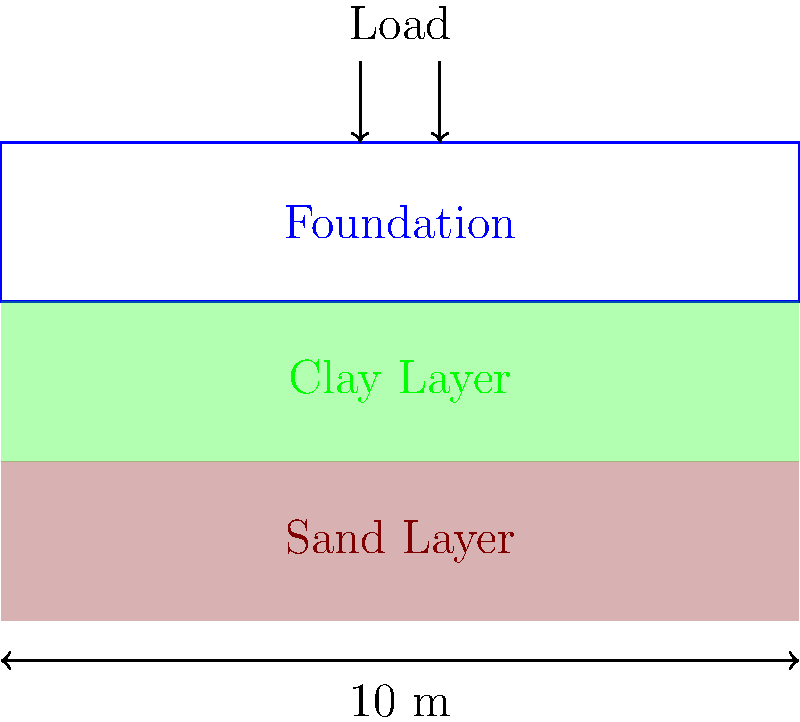A 10-meter wide foundation rests on a two-layer soil profile consisting of a 2-meter thick clay layer over a sand layer. The clay layer has a compression index ($C_c$) of 0.2 and an initial void ratio ($e_0$) of 0.8. The effective overburden pressure ($p_0'$) at the middle of the clay layer is 100 kPa. If a uniform load of 150 kPa is applied to the foundation, what is the estimated settlement of the foundation due to consolidation of the clay layer? Assume the stress increase at the middle of the clay layer is 80% of the applied load. To calculate the settlement of the foundation, we'll use the consolidation settlement equation:

$$S = \frac{C_c H}{1 + e_0} \log_{10}\left(\frac{p_0' + \Delta p}{p_0'}\right)$$

Where:
$S$ = Settlement
$C_c$ = Compression index = 0.2
$H$ = Thickness of the clay layer = 2 m
$e_0$ = Initial void ratio = 0.8
$p_0'$ = Effective overburden pressure = 100 kPa
$\Delta p$ = Stress increase = 80% of 150 kPa = 0.8 × 150 kPa = 120 kPa

Step 1: Calculate the stress increase
$\Delta p = 0.8 \times 150 \text{ kPa} = 120 \text{ kPa}$

Step 2: Apply the consolidation settlement equation
$$S = \frac{0.2 \times 2}{1 + 0.8} \log_{10}\left(\frac{100 + 120}{100}\right)$$

Step 3: Simplify and calculate
$$S = \frac{0.4}{1.8} \log_{10}(2.2)$$
$$S = 0.222 \times 0.342$$
$$S = 0.076 \text{ m}$$

Step 4: Convert to centimeters
$$S = 0.076 \text{ m} \times 100 \text{ cm/m} = 7.6 \text{ cm}$$

Therefore, the estimated settlement of the foundation is 7.6 cm.
Answer: 7.6 cm 